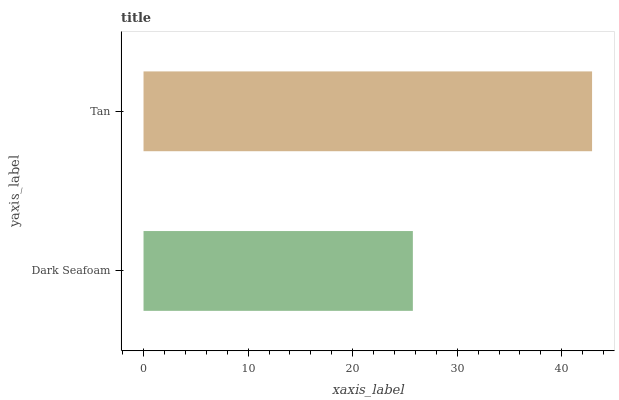Is Dark Seafoam the minimum?
Answer yes or no. Yes. Is Tan the maximum?
Answer yes or no. Yes. Is Tan the minimum?
Answer yes or no. No. Is Tan greater than Dark Seafoam?
Answer yes or no. Yes. Is Dark Seafoam less than Tan?
Answer yes or no. Yes. Is Dark Seafoam greater than Tan?
Answer yes or no. No. Is Tan less than Dark Seafoam?
Answer yes or no. No. Is Tan the high median?
Answer yes or no. Yes. Is Dark Seafoam the low median?
Answer yes or no. Yes. Is Dark Seafoam the high median?
Answer yes or no. No. Is Tan the low median?
Answer yes or no. No. 